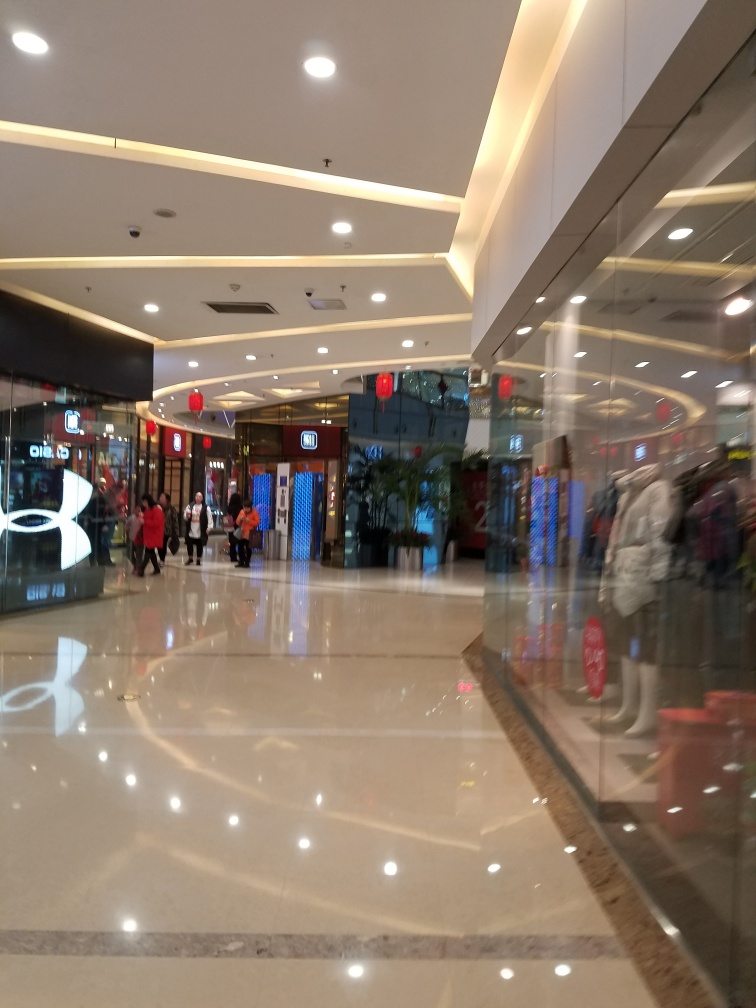How would you describe the mood or atmosphere of the location? The mood of the location appears to be calm and relaxed. Despite being a public space, it doesn't look overcrowded, and the lighting setup along with the reflective surfaces gives off a modern and sophisticated vibe. The presence of festive decorations might indicate a cheerful occasion, contributing to a pleasant atmosphere for the visitors. 